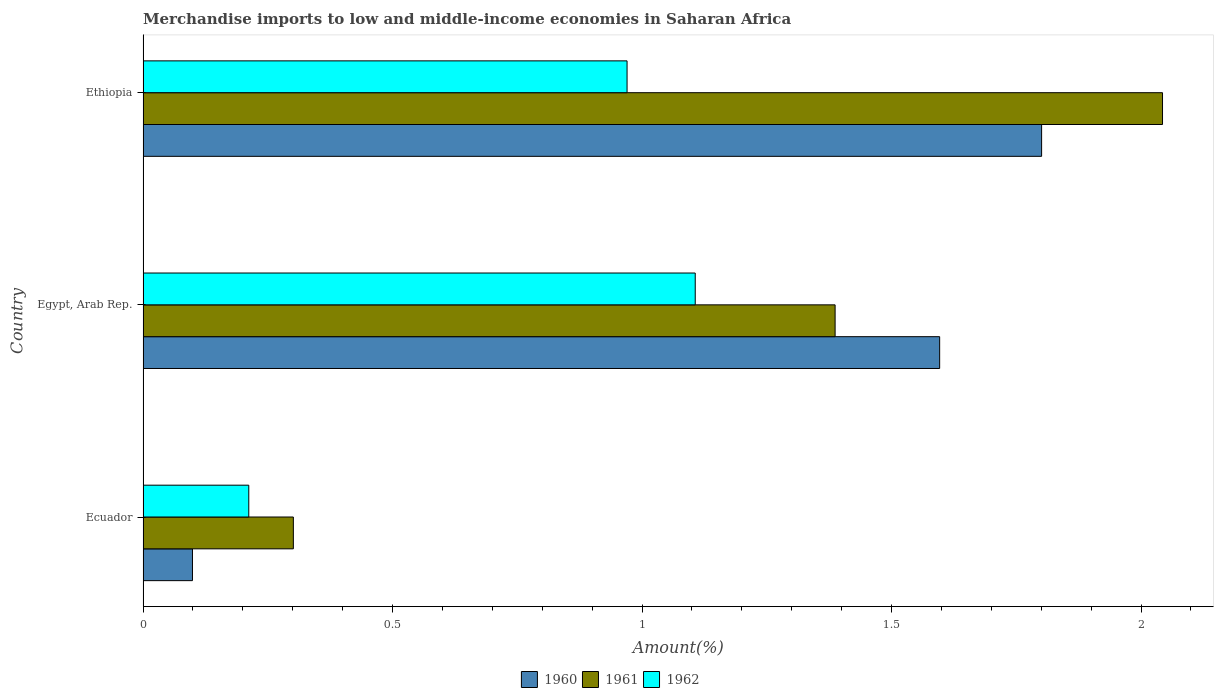How many different coloured bars are there?
Ensure brevity in your answer.  3. How many groups of bars are there?
Your answer should be very brief. 3. How many bars are there on the 3rd tick from the top?
Make the answer very short. 3. How many bars are there on the 1st tick from the bottom?
Offer a very short reply. 3. What is the label of the 3rd group of bars from the top?
Offer a very short reply. Ecuador. What is the percentage of amount earned from merchandise imports in 1962 in Ethiopia?
Offer a very short reply. 0.97. Across all countries, what is the maximum percentage of amount earned from merchandise imports in 1961?
Ensure brevity in your answer.  2.04. Across all countries, what is the minimum percentage of amount earned from merchandise imports in 1960?
Make the answer very short. 0.1. In which country was the percentage of amount earned from merchandise imports in 1962 maximum?
Offer a very short reply. Egypt, Arab Rep. In which country was the percentage of amount earned from merchandise imports in 1960 minimum?
Keep it short and to the point. Ecuador. What is the total percentage of amount earned from merchandise imports in 1960 in the graph?
Make the answer very short. 3.5. What is the difference between the percentage of amount earned from merchandise imports in 1960 in Ecuador and that in Egypt, Arab Rep.?
Give a very brief answer. -1.5. What is the difference between the percentage of amount earned from merchandise imports in 1962 in Ethiopia and the percentage of amount earned from merchandise imports in 1961 in Ecuador?
Offer a terse response. 0.67. What is the average percentage of amount earned from merchandise imports in 1960 per country?
Offer a terse response. 1.17. What is the difference between the percentage of amount earned from merchandise imports in 1961 and percentage of amount earned from merchandise imports in 1962 in Ecuador?
Give a very brief answer. 0.09. What is the ratio of the percentage of amount earned from merchandise imports in 1962 in Ecuador to that in Ethiopia?
Your answer should be very brief. 0.22. Is the percentage of amount earned from merchandise imports in 1962 in Ecuador less than that in Egypt, Arab Rep.?
Provide a short and direct response. Yes. Is the difference between the percentage of amount earned from merchandise imports in 1961 in Ecuador and Egypt, Arab Rep. greater than the difference between the percentage of amount earned from merchandise imports in 1962 in Ecuador and Egypt, Arab Rep.?
Provide a succinct answer. No. What is the difference between the highest and the second highest percentage of amount earned from merchandise imports in 1961?
Keep it short and to the point. 0.66. What is the difference between the highest and the lowest percentage of amount earned from merchandise imports in 1962?
Provide a short and direct response. 0.89. Is the sum of the percentage of amount earned from merchandise imports in 1962 in Ecuador and Ethiopia greater than the maximum percentage of amount earned from merchandise imports in 1960 across all countries?
Give a very brief answer. No. What does the 3rd bar from the top in Ethiopia represents?
Give a very brief answer. 1960. What does the 3rd bar from the bottom in Ethiopia represents?
Provide a succinct answer. 1962. Is it the case that in every country, the sum of the percentage of amount earned from merchandise imports in 1960 and percentage of amount earned from merchandise imports in 1962 is greater than the percentage of amount earned from merchandise imports in 1961?
Offer a terse response. Yes. Are all the bars in the graph horizontal?
Provide a succinct answer. Yes. Does the graph contain any zero values?
Keep it short and to the point. No. Does the graph contain grids?
Ensure brevity in your answer.  No. How many legend labels are there?
Your answer should be compact. 3. How are the legend labels stacked?
Provide a short and direct response. Horizontal. What is the title of the graph?
Provide a succinct answer. Merchandise imports to low and middle-income economies in Saharan Africa. Does "1987" appear as one of the legend labels in the graph?
Ensure brevity in your answer.  No. What is the label or title of the X-axis?
Offer a terse response. Amount(%). What is the Amount(%) of 1960 in Ecuador?
Offer a very short reply. 0.1. What is the Amount(%) in 1961 in Ecuador?
Provide a short and direct response. 0.3. What is the Amount(%) in 1962 in Ecuador?
Your answer should be compact. 0.21. What is the Amount(%) in 1960 in Egypt, Arab Rep.?
Your response must be concise. 1.6. What is the Amount(%) of 1961 in Egypt, Arab Rep.?
Ensure brevity in your answer.  1.39. What is the Amount(%) in 1962 in Egypt, Arab Rep.?
Give a very brief answer. 1.11. What is the Amount(%) in 1960 in Ethiopia?
Make the answer very short. 1.8. What is the Amount(%) of 1961 in Ethiopia?
Keep it short and to the point. 2.04. What is the Amount(%) of 1962 in Ethiopia?
Offer a very short reply. 0.97. Across all countries, what is the maximum Amount(%) of 1960?
Provide a short and direct response. 1.8. Across all countries, what is the maximum Amount(%) of 1961?
Keep it short and to the point. 2.04. Across all countries, what is the maximum Amount(%) of 1962?
Offer a terse response. 1.11. Across all countries, what is the minimum Amount(%) of 1960?
Offer a terse response. 0.1. Across all countries, what is the minimum Amount(%) in 1961?
Offer a very short reply. 0.3. Across all countries, what is the minimum Amount(%) of 1962?
Provide a short and direct response. 0.21. What is the total Amount(%) of 1960 in the graph?
Provide a succinct answer. 3.5. What is the total Amount(%) of 1961 in the graph?
Give a very brief answer. 3.73. What is the total Amount(%) in 1962 in the graph?
Your response must be concise. 2.29. What is the difference between the Amount(%) in 1960 in Ecuador and that in Egypt, Arab Rep.?
Offer a terse response. -1.5. What is the difference between the Amount(%) in 1961 in Ecuador and that in Egypt, Arab Rep.?
Offer a very short reply. -1.09. What is the difference between the Amount(%) of 1962 in Ecuador and that in Egypt, Arab Rep.?
Your response must be concise. -0.89. What is the difference between the Amount(%) of 1960 in Ecuador and that in Ethiopia?
Give a very brief answer. -1.7. What is the difference between the Amount(%) in 1961 in Ecuador and that in Ethiopia?
Give a very brief answer. -1.74. What is the difference between the Amount(%) in 1962 in Ecuador and that in Ethiopia?
Your response must be concise. -0.76. What is the difference between the Amount(%) in 1960 in Egypt, Arab Rep. and that in Ethiopia?
Offer a very short reply. -0.2. What is the difference between the Amount(%) of 1961 in Egypt, Arab Rep. and that in Ethiopia?
Your answer should be compact. -0.66. What is the difference between the Amount(%) of 1962 in Egypt, Arab Rep. and that in Ethiopia?
Your answer should be very brief. 0.14. What is the difference between the Amount(%) in 1960 in Ecuador and the Amount(%) in 1961 in Egypt, Arab Rep.?
Give a very brief answer. -1.29. What is the difference between the Amount(%) in 1960 in Ecuador and the Amount(%) in 1962 in Egypt, Arab Rep.?
Your answer should be very brief. -1.01. What is the difference between the Amount(%) of 1961 in Ecuador and the Amount(%) of 1962 in Egypt, Arab Rep.?
Make the answer very short. -0.81. What is the difference between the Amount(%) in 1960 in Ecuador and the Amount(%) in 1961 in Ethiopia?
Keep it short and to the point. -1.94. What is the difference between the Amount(%) in 1960 in Ecuador and the Amount(%) in 1962 in Ethiopia?
Provide a short and direct response. -0.87. What is the difference between the Amount(%) in 1961 in Ecuador and the Amount(%) in 1962 in Ethiopia?
Keep it short and to the point. -0.67. What is the difference between the Amount(%) in 1960 in Egypt, Arab Rep. and the Amount(%) in 1961 in Ethiopia?
Offer a terse response. -0.45. What is the difference between the Amount(%) in 1960 in Egypt, Arab Rep. and the Amount(%) in 1962 in Ethiopia?
Offer a terse response. 0.63. What is the difference between the Amount(%) in 1961 in Egypt, Arab Rep. and the Amount(%) in 1962 in Ethiopia?
Offer a terse response. 0.42. What is the average Amount(%) of 1960 per country?
Ensure brevity in your answer.  1.17. What is the average Amount(%) of 1961 per country?
Give a very brief answer. 1.24. What is the average Amount(%) of 1962 per country?
Offer a terse response. 0.76. What is the difference between the Amount(%) of 1960 and Amount(%) of 1961 in Ecuador?
Provide a succinct answer. -0.2. What is the difference between the Amount(%) of 1960 and Amount(%) of 1962 in Ecuador?
Make the answer very short. -0.11. What is the difference between the Amount(%) in 1961 and Amount(%) in 1962 in Ecuador?
Provide a succinct answer. 0.09. What is the difference between the Amount(%) in 1960 and Amount(%) in 1961 in Egypt, Arab Rep.?
Offer a terse response. 0.21. What is the difference between the Amount(%) in 1960 and Amount(%) in 1962 in Egypt, Arab Rep.?
Offer a very short reply. 0.49. What is the difference between the Amount(%) of 1961 and Amount(%) of 1962 in Egypt, Arab Rep.?
Provide a succinct answer. 0.28. What is the difference between the Amount(%) of 1960 and Amount(%) of 1961 in Ethiopia?
Keep it short and to the point. -0.24. What is the difference between the Amount(%) in 1960 and Amount(%) in 1962 in Ethiopia?
Give a very brief answer. 0.83. What is the difference between the Amount(%) in 1961 and Amount(%) in 1962 in Ethiopia?
Ensure brevity in your answer.  1.07. What is the ratio of the Amount(%) of 1960 in Ecuador to that in Egypt, Arab Rep.?
Your answer should be compact. 0.06. What is the ratio of the Amount(%) of 1961 in Ecuador to that in Egypt, Arab Rep.?
Ensure brevity in your answer.  0.22. What is the ratio of the Amount(%) in 1962 in Ecuador to that in Egypt, Arab Rep.?
Keep it short and to the point. 0.19. What is the ratio of the Amount(%) of 1960 in Ecuador to that in Ethiopia?
Your answer should be compact. 0.06. What is the ratio of the Amount(%) of 1961 in Ecuador to that in Ethiopia?
Your answer should be very brief. 0.15. What is the ratio of the Amount(%) of 1962 in Ecuador to that in Ethiopia?
Your answer should be very brief. 0.22. What is the ratio of the Amount(%) of 1960 in Egypt, Arab Rep. to that in Ethiopia?
Ensure brevity in your answer.  0.89. What is the ratio of the Amount(%) of 1961 in Egypt, Arab Rep. to that in Ethiopia?
Offer a terse response. 0.68. What is the ratio of the Amount(%) of 1962 in Egypt, Arab Rep. to that in Ethiopia?
Give a very brief answer. 1.14. What is the difference between the highest and the second highest Amount(%) in 1960?
Your answer should be compact. 0.2. What is the difference between the highest and the second highest Amount(%) in 1961?
Provide a short and direct response. 0.66. What is the difference between the highest and the second highest Amount(%) of 1962?
Offer a terse response. 0.14. What is the difference between the highest and the lowest Amount(%) of 1960?
Offer a terse response. 1.7. What is the difference between the highest and the lowest Amount(%) of 1961?
Provide a succinct answer. 1.74. What is the difference between the highest and the lowest Amount(%) in 1962?
Keep it short and to the point. 0.89. 